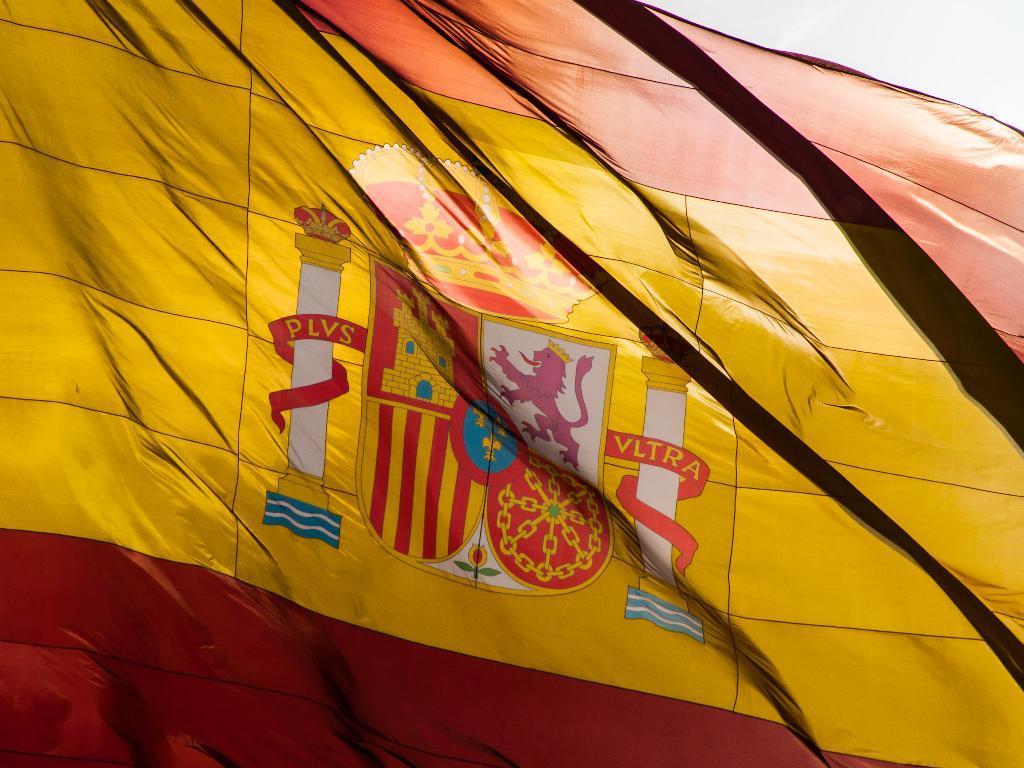Could you give a brief overview of what you see in this image? This image is taken outdoors. In this image there is a flag. 